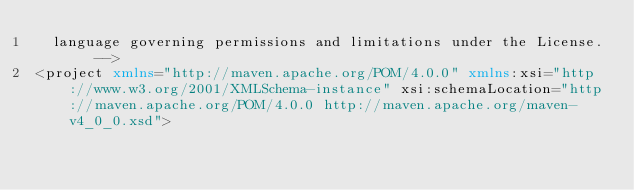Convert code to text. <code><loc_0><loc_0><loc_500><loc_500><_XML_>	language governing permissions and limitations under the License. -->
<project xmlns="http://maven.apache.org/POM/4.0.0" xmlns:xsi="http://www.w3.org/2001/XMLSchema-instance" xsi:schemaLocation="http://maven.apache.org/POM/4.0.0 http://maven.apache.org/maven-v4_0_0.xsd"></code> 